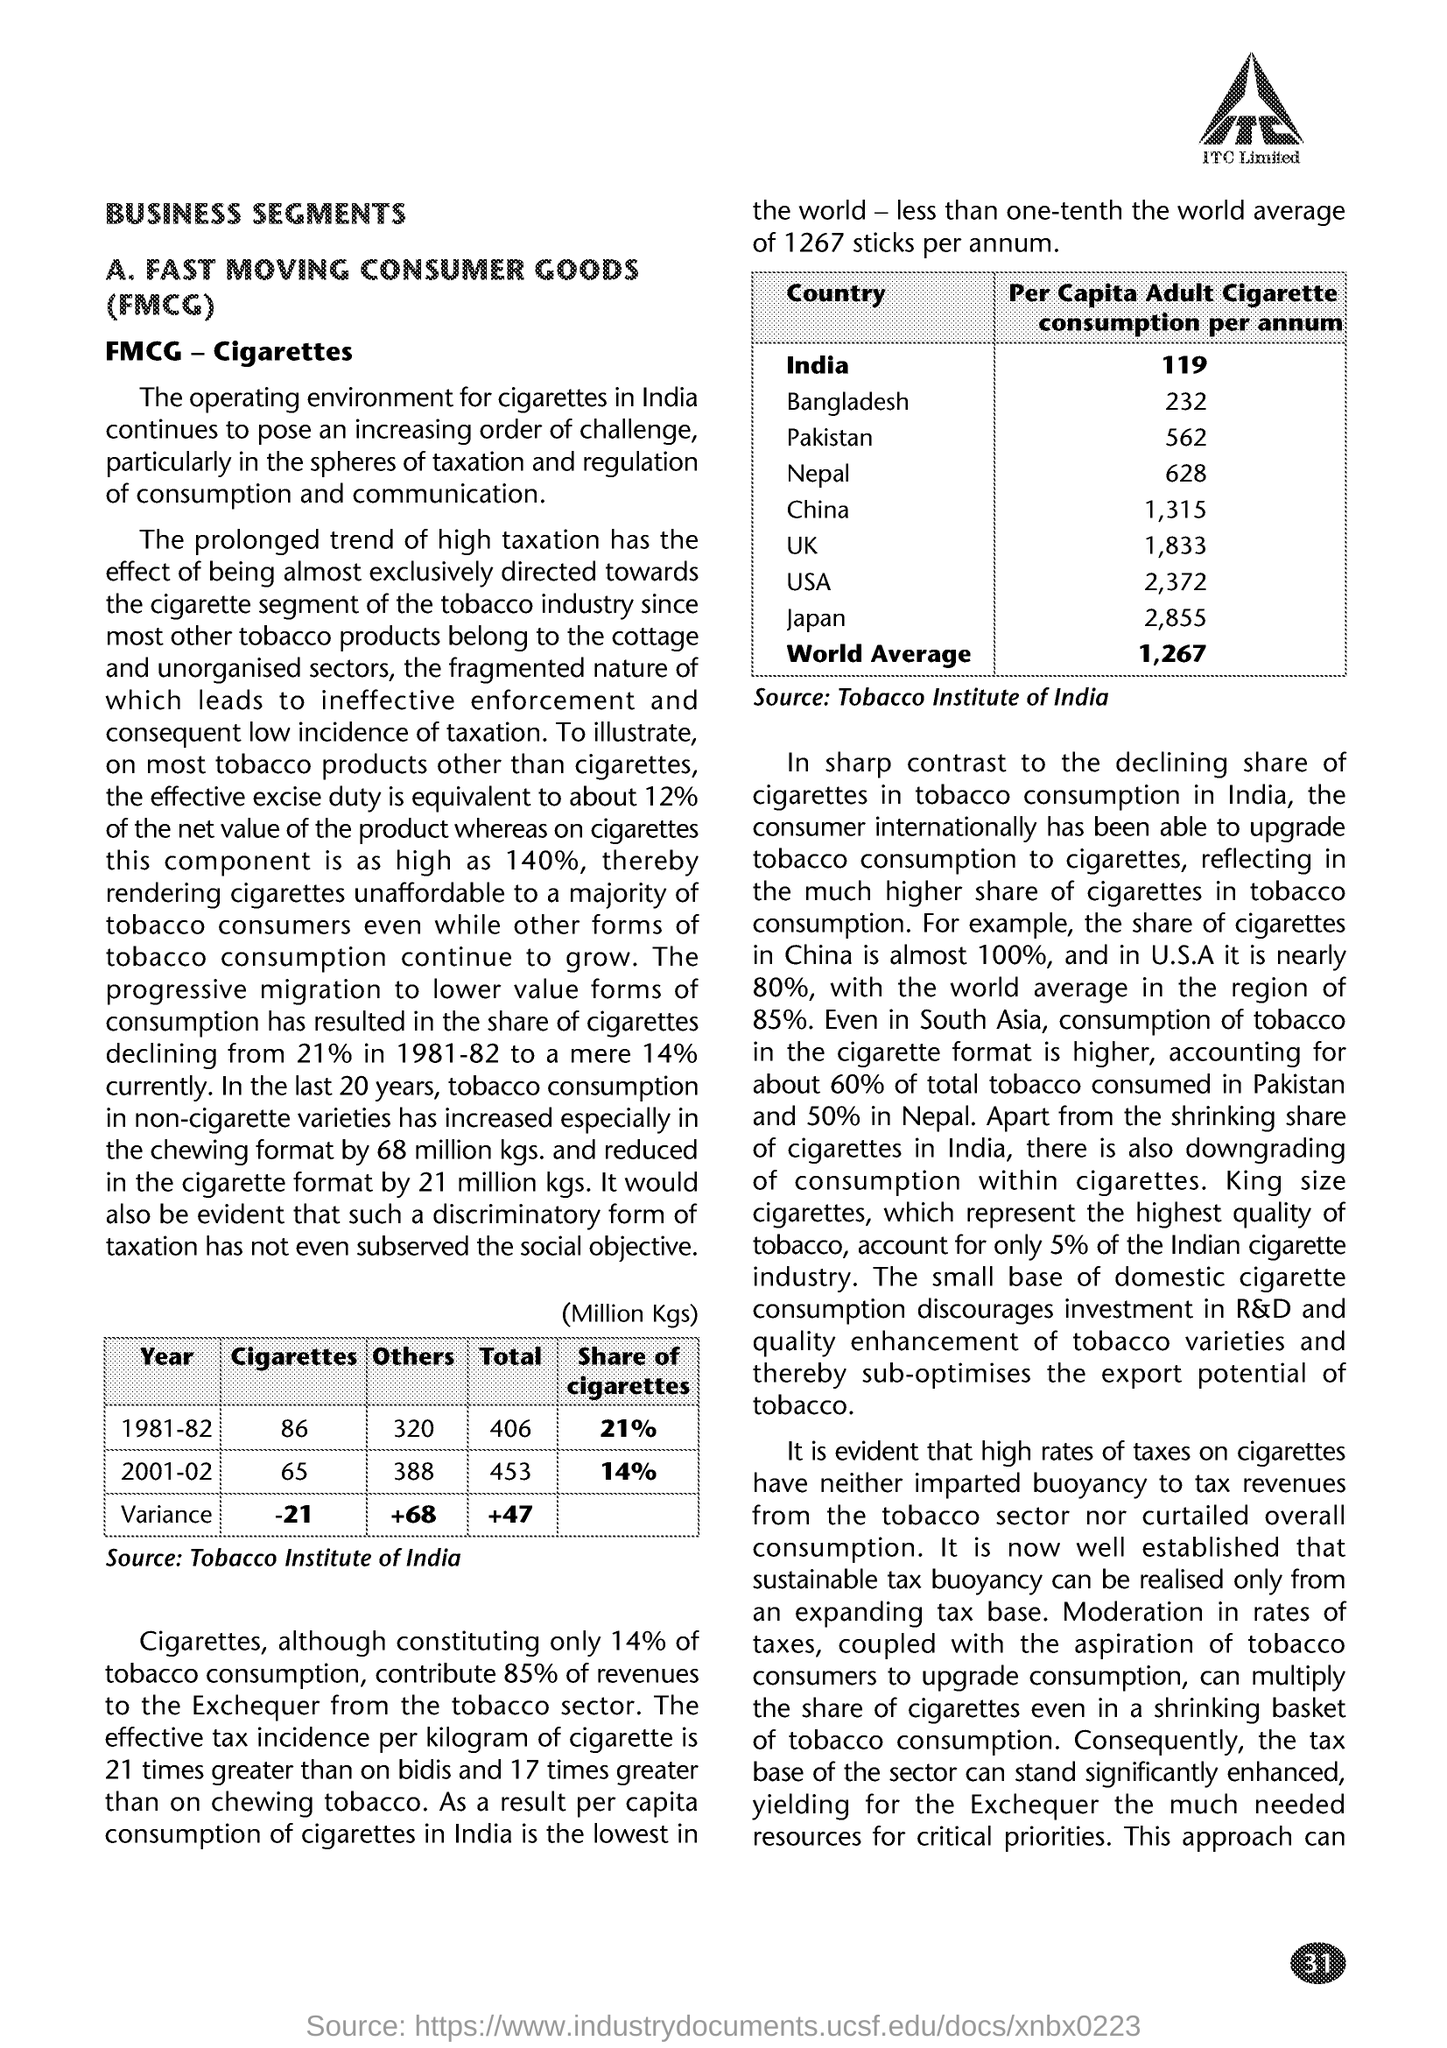What is the main heading of document ?
Give a very brief answer. BUSINESS SEGMENTS. What is the Fullform of FMCG ?
Provide a succinct answer. Fast moving consumer goods. What is the Share of cigarettes in the 1981-82 ?
Make the answer very short. 21%. How much Per Capita Adult Cigarette consumption per annum at USA ?
Give a very brief answer. 2,372. How much World Average Per capita Adult Cigarette consumption per annum ?
Keep it short and to the point. 1,267. 